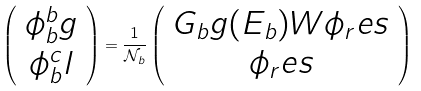Convert formula to latex. <formula><loc_0><loc_0><loc_500><loc_500>\left ( \begin{array} { c } \phi _ { b } ^ { b } g \\ \phi _ { b } ^ { c } l \end{array} \right ) = \frac { 1 } { \mathcal { N } _ { b } } \left ( \begin{array} { c } G _ { b } g ( E _ { b } ) W \phi _ { r } e s \\ \phi _ { r } e s \end{array} \right )</formula> 